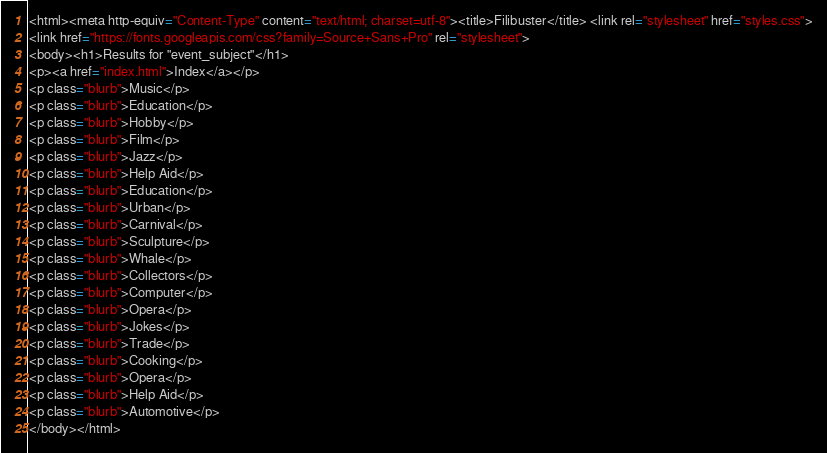<code> <loc_0><loc_0><loc_500><loc_500><_HTML_><html><meta http-equiv="Content-Type" content="text/html; charset=utf-8"><title>Filibuster</title> <link rel="stylesheet" href="styles.css">
<link href="https://fonts.googleapis.com/css?family=Source+Sans+Pro" rel="stylesheet">
<body><h1>Results for "event_subject"</h1>
<p><a href="index.html">Index</a></p>
<p class="blurb">Music</p>
<p class="blurb">Education</p>
<p class="blurb">Hobby</p>
<p class="blurb">Film</p>
<p class="blurb">Jazz</p>
<p class="blurb">Help Aid</p>
<p class="blurb">Education</p>
<p class="blurb">Urban</p>
<p class="blurb">Carnival</p>
<p class="blurb">Sculpture</p>
<p class="blurb">Whale</p>
<p class="blurb">Collectors</p>
<p class="blurb">Computer</p>
<p class="blurb">Opera</p>
<p class="blurb">Jokes</p>
<p class="blurb">Trade</p>
<p class="blurb">Cooking</p>
<p class="blurb">Opera</p>
<p class="blurb">Help Aid</p>
<p class="blurb">Automotive</p>
</body></html></code> 